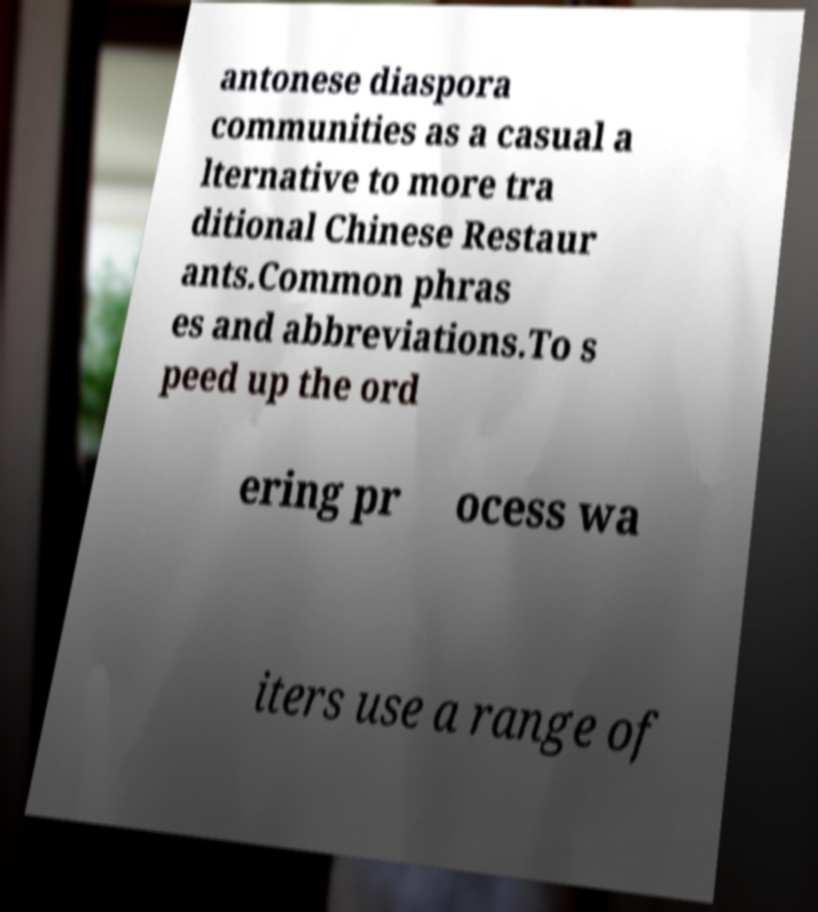Can you read and provide the text displayed in the image?This photo seems to have some interesting text. Can you extract and type it out for me? antonese diaspora communities as a casual a lternative to more tra ditional Chinese Restaur ants.Common phras es and abbreviations.To s peed up the ord ering pr ocess wa iters use a range of 